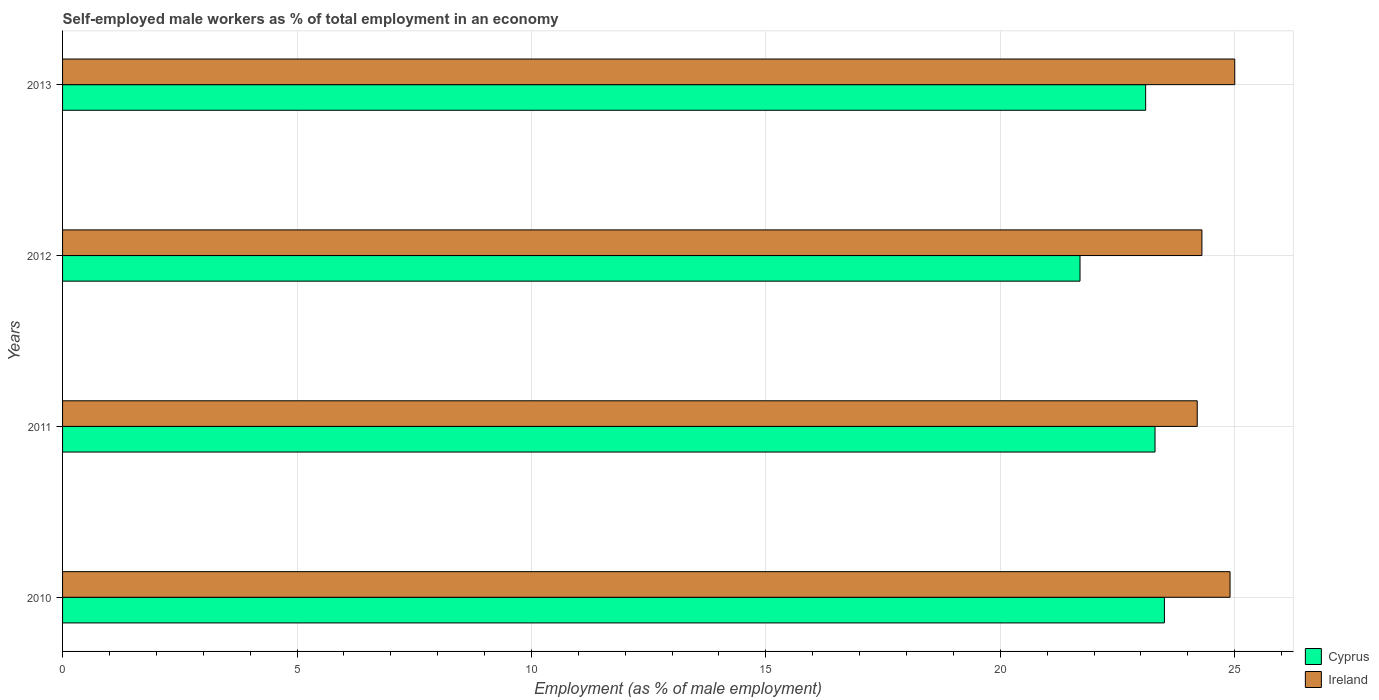How many different coloured bars are there?
Your answer should be compact. 2. Are the number of bars per tick equal to the number of legend labels?
Give a very brief answer. Yes. Are the number of bars on each tick of the Y-axis equal?
Ensure brevity in your answer.  Yes. Across all years, what is the minimum percentage of self-employed male workers in Ireland?
Provide a short and direct response. 24.2. In which year was the percentage of self-employed male workers in Ireland maximum?
Offer a terse response. 2013. What is the total percentage of self-employed male workers in Ireland in the graph?
Offer a very short reply. 98.4. What is the difference between the percentage of self-employed male workers in Ireland in 2010 and that in 2012?
Offer a very short reply. 0.6. What is the difference between the percentage of self-employed male workers in Ireland in 2013 and the percentage of self-employed male workers in Cyprus in 2012?
Give a very brief answer. 3.3. What is the average percentage of self-employed male workers in Ireland per year?
Your response must be concise. 24.6. In the year 2013, what is the difference between the percentage of self-employed male workers in Cyprus and percentage of self-employed male workers in Ireland?
Give a very brief answer. -1.9. In how many years, is the percentage of self-employed male workers in Ireland greater than 21 %?
Provide a short and direct response. 4. What is the ratio of the percentage of self-employed male workers in Cyprus in 2011 to that in 2012?
Keep it short and to the point. 1.07. Is the percentage of self-employed male workers in Ireland in 2010 less than that in 2011?
Your answer should be very brief. No. What is the difference between the highest and the second highest percentage of self-employed male workers in Ireland?
Offer a terse response. 0.1. What is the difference between the highest and the lowest percentage of self-employed male workers in Cyprus?
Your answer should be compact. 1.8. Is the sum of the percentage of self-employed male workers in Ireland in 2010 and 2011 greater than the maximum percentage of self-employed male workers in Cyprus across all years?
Ensure brevity in your answer.  Yes. What does the 2nd bar from the top in 2012 represents?
Provide a succinct answer. Cyprus. What does the 2nd bar from the bottom in 2012 represents?
Offer a terse response. Ireland. How many bars are there?
Provide a short and direct response. 8. Are all the bars in the graph horizontal?
Your response must be concise. Yes. Are the values on the major ticks of X-axis written in scientific E-notation?
Provide a succinct answer. No. Does the graph contain grids?
Give a very brief answer. Yes. What is the title of the graph?
Keep it short and to the point. Self-employed male workers as % of total employment in an economy. Does "China" appear as one of the legend labels in the graph?
Offer a very short reply. No. What is the label or title of the X-axis?
Your answer should be very brief. Employment (as % of male employment). What is the label or title of the Y-axis?
Provide a succinct answer. Years. What is the Employment (as % of male employment) of Ireland in 2010?
Ensure brevity in your answer.  24.9. What is the Employment (as % of male employment) in Cyprus in 2011?
Your response must be concise. 23.3. What is the Employment (as % of male employment) of Ireland in 2011?
Make the answer very short. 24.2. What is the Employment (as % of male employment) of Cyprus in 2012?
Give a very brief answer. 21.7. What is the Employment (as % of male employment) in Ireland in 2012?
Make the answer very short. 24.3. What is the Employment (as % of male employment) of Cyprus in 2013?
Provide a succinct answer. 23.1. What is the Employment (as % of male employment) of Ireland in 2013?
Offer a terse response. 25. Across all years, what is the maximum Employment (as % of male employment) of Cyprus?
Your answer should be very brief. 23.5. Across all years, what is the maximum Employment (as % of male employment) in Ireland?
Ensure brevity in your answer.  25. Across all years, what is the minimum Employment (as % of male employment) of Cyprus?
Offer a very short reply. 21.7. Across all years, what is the minimum Employment (as % of male employment) of Ireland?
Provide a succinct answer. 24.2. What is the total Employment (as % of male employment) of Cyprus in the graph?
Ensure brevity in your answer.  91.6. What is the total Employment (as % of male employment) of Ireland in the graph?
Make the answer very short. 98.4. What is the difference between the Employment (as % of male employment) of Cyprus in 2010 and that in 2012?
Provide a short and direct response. 1.8. What is the difference between the Employment (as % of male employment) in Cyprus in 2010 and that in 2013?
Give a very brief answer. 0.4. What is the difference between the Employment (as % of male employment) in Ireland in 2010 and that in 2013?
Keep it short and to the point. -0.1. What is the difference between the Employment (as % of male employment) in Cyprus in 2011 and that in 2012?
Offer a very short reply. 1.6. What is the difference between the Employment (as % of male employment) of Cyprus in 2011 and that in 2013?
Keep it short and to the point. 0.2. What is the difference between the Employment (as % of male employment) of Cyprus in 2012 and that in 2013?
Your answer should be compact. -1.4. What is the difference between the Employment (as % of male employment) of Ireland in 2012 and that in 2013?
Provide a succinct answer. -0.7. What is the difference between the Employment (as % of male employment) in Cyprus in 2010 and the Employment (as % of male employment) in Ireland in 2011?
Your answer should be very brief. -0.7. What is the difference between the Employment (as % of male employment) in Cyprus in 2010 and the Employment (as % of male employment) in Ireland in 2012?
Give a very brief answer. -0.8. What is the difference between the Employment (as % of male employment) in Cyprus in 2010 and the Employment (as % of male employment) in Ireland in 2013?
Offer a very short reply. -1.5. What is the difference between the Employment (as % of male employment) of Cyprus in 2011 and the Employment (as % of male employment) of Ireland in 2012?
Offer a terse response. -1. What is the difference between the Employment (as % of male employment) of Cyprus in 2011 and the Employment (as % of male employment) of Ireland in 2013?
Your response must be concise. -1.7. What is the difference between the Employment (as % of male employment) in Cyprus in 2012 and the Employment (as % of male employment) in Ireland in 2013?
Provide a short and direct response. -3.3. What is the average Employment (as % of male employment) in Cyprus per year?
Give a very brief answer. 22.9. What is the average Employment (as % of male employment) in Ireland per year?
Your answer should be compact. 24.6. In the year 2012, what is the difference between the Employment (as % of male employment) of Cyprus and Employment (as % of male employment) of Ireland?
Provide a short and direct response. -2.6. What is the ratio of the Employment (as % of male employment) of Cyprus in 2010 to that in 2011?
Offer a very short reply. 1.01. What is the ratio of the Employment (as % of male employment) in Ireland in 2010 to that in 2011?
Give a very brief answer. 1.03. What is the ratio of the Employment (as % of male employment) of Cyprus in 2010 to that in 2012?
Give a very brief answer. 1.08. What is the ratio of the Employment (as % of male employment) of Ireland in 2010 to that in 2012?
Your response must be concise. 1.02. What is the ratio of the Employment (as % of male employment) in Cyprus in 2010 to that in 2013?
Give a very brief answer. 1.02. What is the ratio of the Employment (as % of male employment) in Cyprus in 2011 to that in 2012?
Provide a succinct answer. 1.07. What is the ratio of the Employment (as % of male employment) of Cyprus in 2011 to that in 2013?
Your answer should be very brief. 1.01. What is the ratio of the Employment (as % of male employment) in Cyprus in 2012 to that in 2013?
Your response must be concise. 0.94. What is the ratio of the Employment (as % of male employment) of Ireland in 2012 to that in 2013?
Make the answer very short. 0.97. What is the difference between the highest and the second highest Employment (as % of male employment) in Cyprus?
Give a very brief answer. 0.2. What is the difference between the highest and the second highest Employment (as % of male employment) in Ireland?
Offer a terse response. 0.1. What is the difference between the highest and the lowest Employment (as % of male employment) in Ireland?
Ensure brevity in your answer.  0.8. 